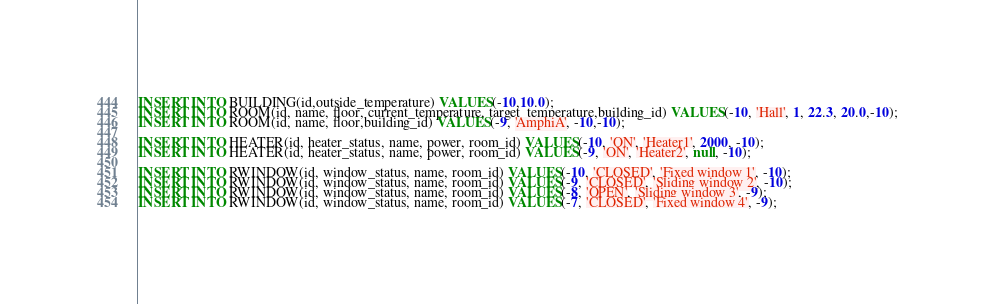Convert code to text. <code><loc_0><loc_0><loc_500><loc_500><_SQL_>INSERT INTO BUILDING(id,outside_temperature) VALUES(-10,10.0);
INSERT INTO ROOM(id, name, floor, current_temperature, target_temperature,building_id) VALUES(-10, 'Hall', 1, 22.3, 20.0,-10);
INSERT INTO ROOM(id, name, floor,building_id) VALUES(-9, 'AmphiA', -10,-10);

INSERT INTO HEATER(id, heater_status, name, power, room_id) VALUES(-10, 'ON', 'Heater1', 2000, -10);
INSERT INTO HEATER(id, heater_status, name, power, room_id) VALUES(-9, 'ON', 'Heater2', null, -10);

INSERT INTO RWINDOW(id, window_status, name, room_id) VALUES(-10, 'CLOSED', 'Fixed window 1', -10);
INSERT INTO RWINDOW(id, window_status, name, room_id) VALUES(-9, 'CLOSED', 'Sliding window 2', -10);
INSERT INTO RWINDOW(id, window_status, name, room_id) VALUES(-8, 'OPEN', 'Sliding window 3', -9);
INSERT INTO RWINDOW(id, window_status, name, room_id) VALUES(-7, 'CLOSED', 'Fixed window 4', -9);</code> 